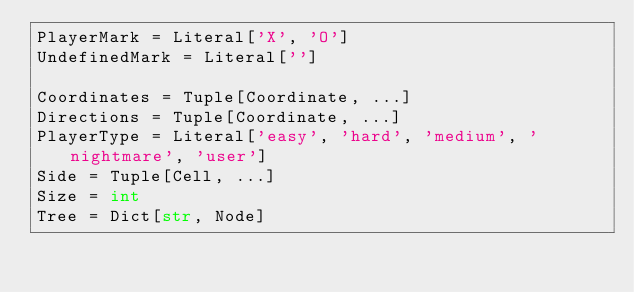Convert code to text. <code><loc_0><loc_0><loc_500><loc_500><_Python_>PlayerMark = Literal['X', 'O']
UndefinedMark = Literal['']

Coordinates = Tuple[Coordinate, ...]
Directions = Tuple[Coordinate, ...]
PlayerType = Literal['easy', 'hard', 'medium', 'nightmare', 'user']
Side = Tuple[Cell, ...]
Size = int
Tree = Dict[str, Node]
</code> 